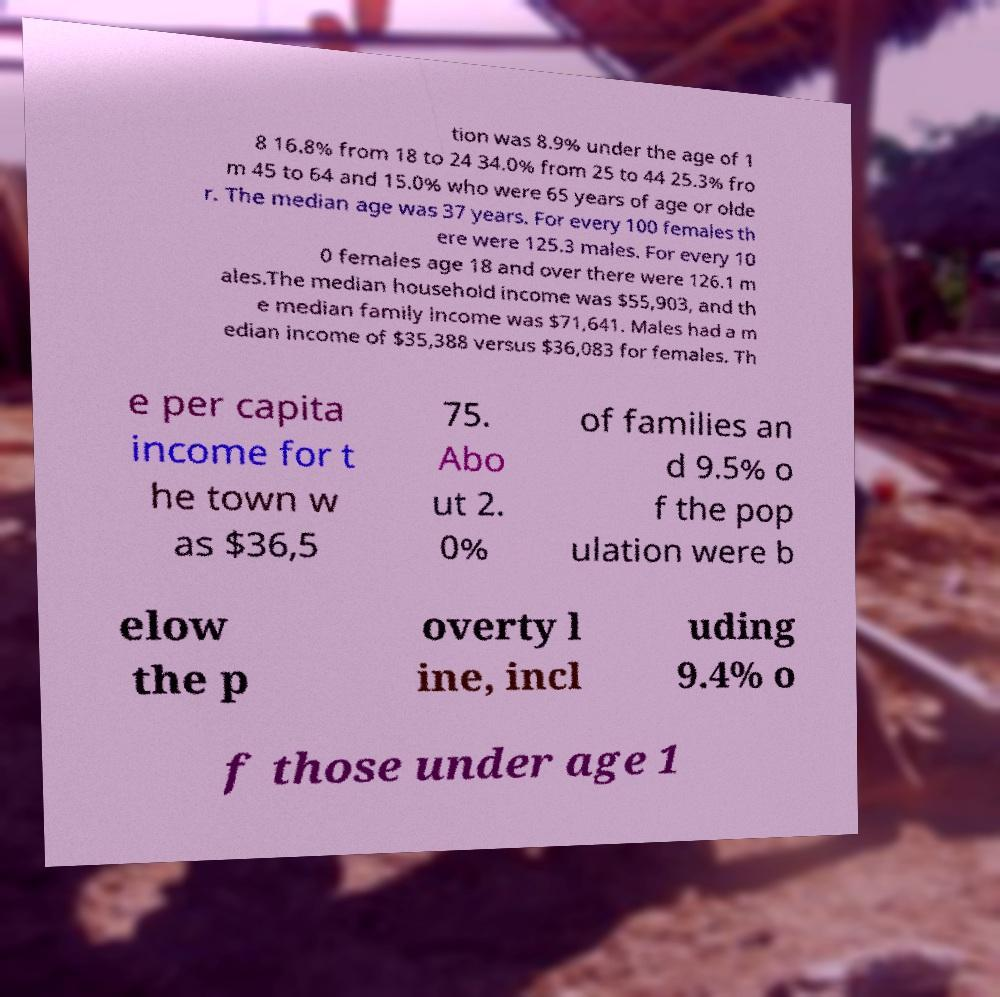Could you assist in decoding the text presented in this image and type it out clearly? tion was 8.9% under the age of 1 8 16.8% from 18 to 24 34.0% from 25 to 44 25.3% fro m 45 to 64 and 15.0% who were 65 years of age or olde r. The median age was 37 years. For every 100 females th ere were 125.3 males. For every 10 0 females age 18 and over there were 126.1 m ales.The median household income was $55,903, and th e median family income was $71,641. Males had a m edian income of $35,388 versus $36,083 for females. Th e per capita income for t he town w as $36,5 75. Abo ut 2. 0% of families an d 9.5% o f the pop ulation were b elow the p overty l ine, incl uding 9.4% o f those under age 1 